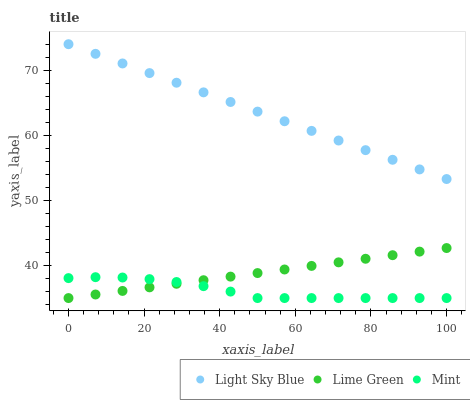Does Mint have the minimum area under the curve?
Answer yes or no. Yes. Does Light Sky Blue have the maximum area under the curve?
Answer yes or no. Yes. Does Lime Green have the minimum area under the curve?
Answer yes or no. No. Does Lime Green have the maximum area under the curve?
Answer yes or no. No. Is Lime Green the smoothest?
Answer yes or no. Yes. Is Mint the roughest?
Answer yes or no. Yes. Is Light Sky Blue the smoothest?
Answer yes or no. No. Is Light Sky Blue the roughest?
Answer yes or no. No. Does Mint have the lowest value?
Answer yes or no. Yes. Does Light Sky Blue have the lowest value?
Answer yes or no. No. Does Light Sky Blue have the highest value?
Answer yes or no. Yes. Does Lime Green have the highest value?
Answer yes or no. No. Is Lime Green less than Light Sky Blue?
Answer yes or no. Yes. Is Light Sky Blue greater than Lime Green?
Answer yes or no. Yes. Does Lime Green intersect Mint?
Answer yes or no. Yes. Is Lime Green less than Mint?
Answer yes or no. No. Is Lime Green greater than Mint?
Answer yes or no. No. Does Lime Green intersect Light Sky Blue?
Answer yes or no. No. 